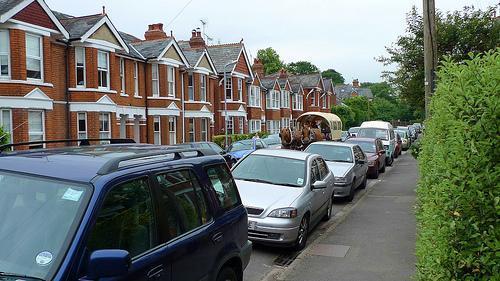How many blue vans are depicted?
Give a very brief answer. 1. How many horses are there?
Give a very brief answer. 2. 